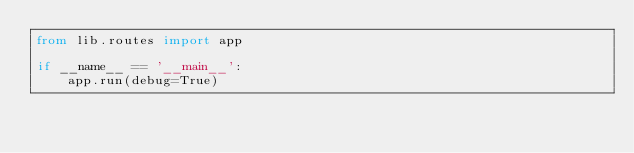Convert code to text. <code><loc_0><loc_0><loc_500><loc_500><_Python_>from lib.routes import app

if __name__ == '__main__':
    app.run(debug=True)
</code> 